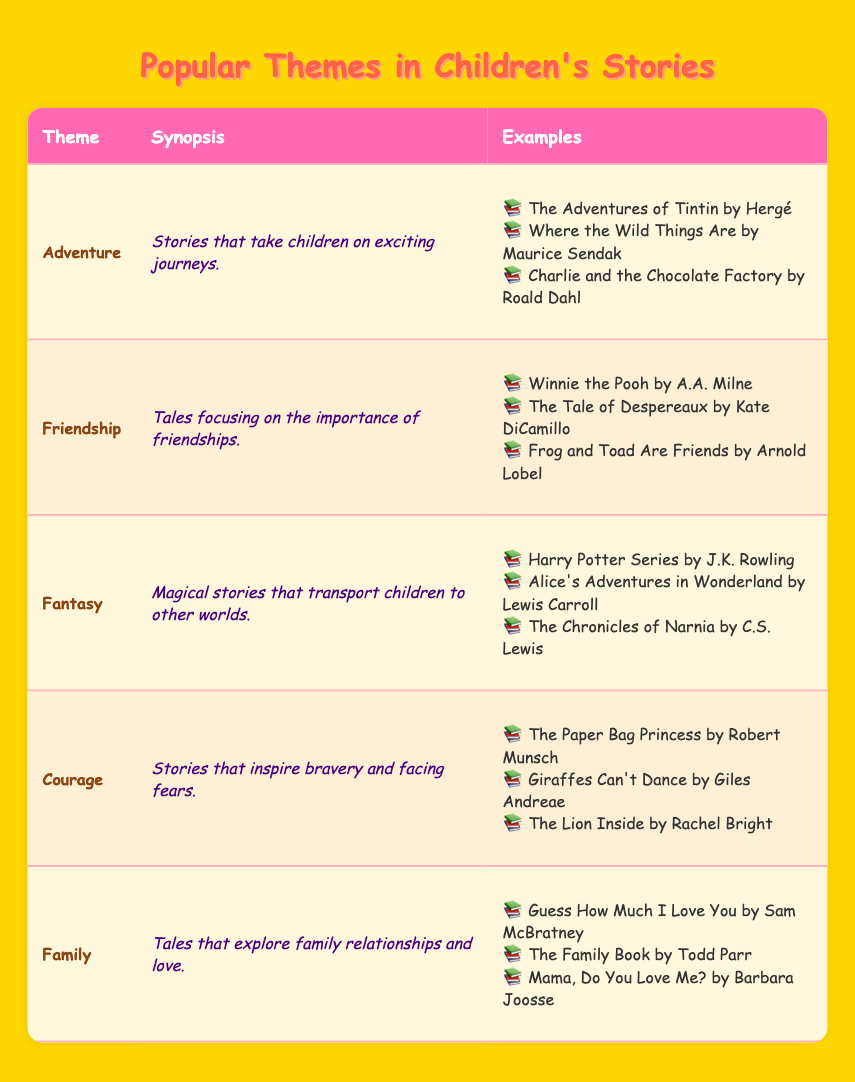What theme focuses on exciting journeys? The table lists different themes in children's stories, and "Adventure" is described as stories that take children on exciting journeys.
Answer: Adventure Which story is an example of the Fantasy theme? The table provides examples of stories under each theme, and for the Fantasy theme, one of the examples listed is "Harry Potter Series by J.K. Rowling."
Answer: Harry Potter Series by J.K. Rowling Are there any stories in the Family theme that explore love? Looking at the Family theme in the table, examples such as "Guess How Much I Love You by Sam McBratney" show that this theme explores family relationships and love. Therefore, the answer is yes.
Answer: Yes How many themes are listed in the table? The table includes five themes: Adventure, Friendship, Fantasy, Courage, and Family. Counting these gives us a total of five themes.
Answer: 5 Which theme has the least number of examples? By examining the list of examples under each theme in the table, all themes have three examples. Thus, they all have the same number.
Answer: All themes have the same number What are the themes that include stories about bravery? The table specifically mentions the "Courage" theme as stories that inspire bravery and facing fears. Therefore, the answer is that only the Courage theme includes this.
Answer: Courage How many different authors are mentioned in the examples? The table lists examples from various themes, and by counting distinct authors from the examples under each theme, we find there are seven different authors: Hergé, Maurice Sendak, Roald Dahl, A.A. Milne, Kate DiCamillo, Arnold Lobel, J.K. Rowling, Lewis Carroll, C.S. Lewis, Robert Munsch, Giles Andreae, Rachel Bright, Sam McBratney, Todd Parr, and Barbara Joosse. This results in a total of fifteen different authors.
Answer: 15 Is there a theme that has a story written by a specific author, like Roald Dahl? Checking the examples listed under each theme reveals that Roald Dahl is associated with the Adventure theme, where "Charlie and the Chocolate Factory" is mentioned. Hence, it is confirmed.
Answer: Yes 